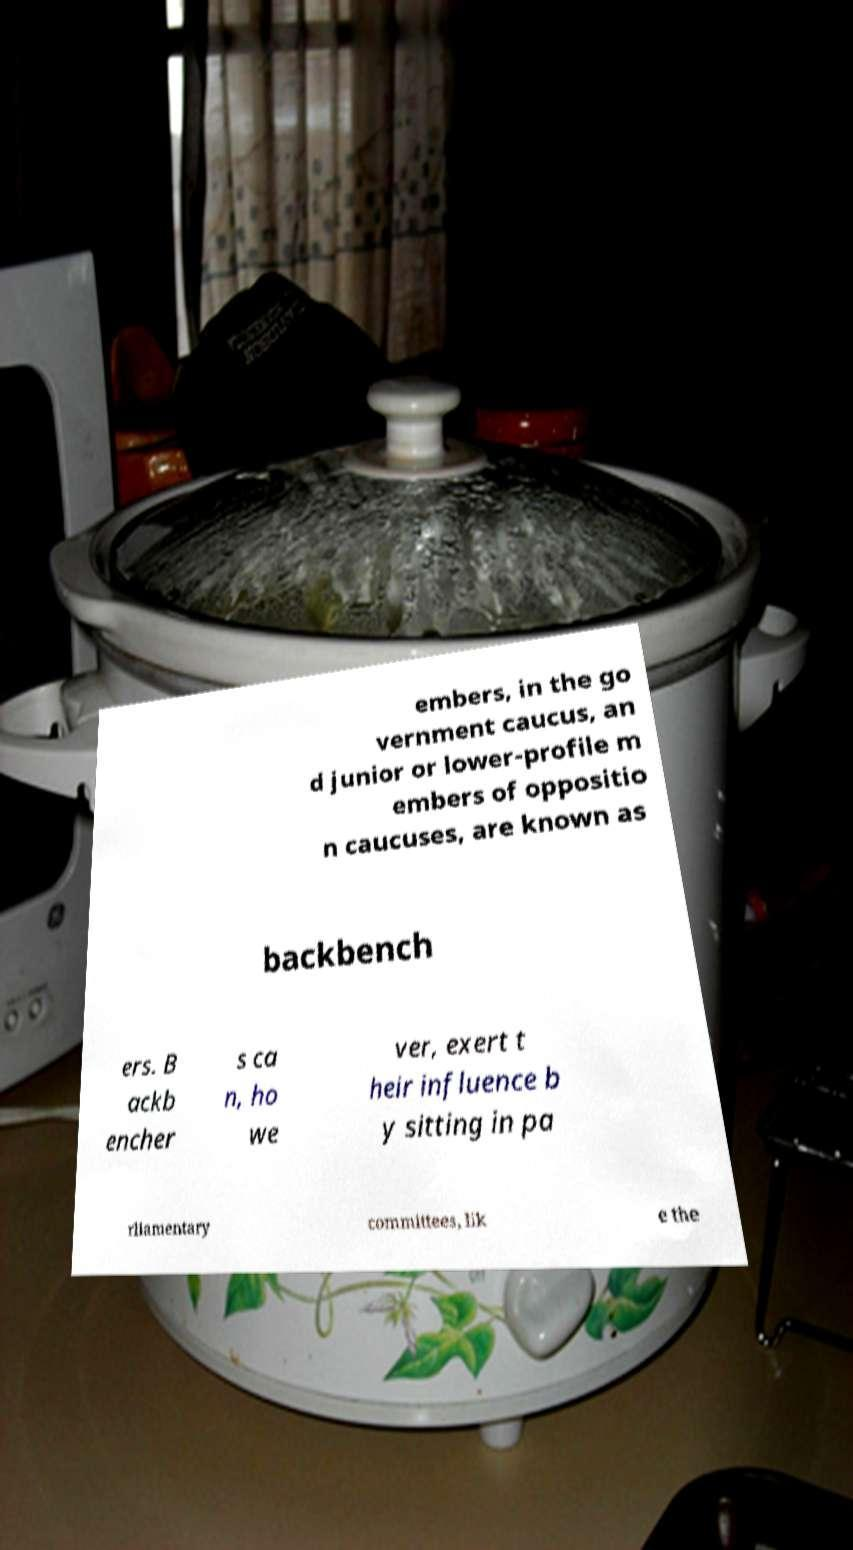Please read and relay the text visible in this image. What does it say? embers, in the go vernment caucus, an d junior or lower-profile m embers of oppositio n caucuses, are known as backbench ers. B ackb encher s ca n, ho we ver, exert t heir influence b y sitting in pa rliamentary committees, lik e the 